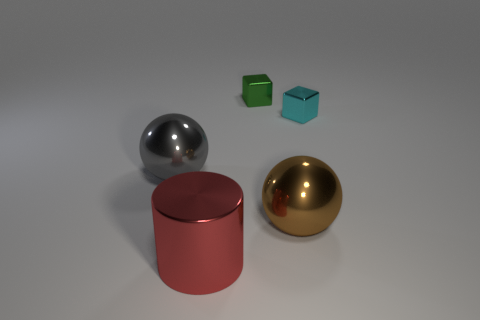Is the size of the shiny cylinder the same as the green metal cube?
Keep it short and to the point. No. Is the material of the large ball right of the large gray shiny ball the same as the tiny object that is behind the small cyan metal object?
Offer a very short reply. Yes. The object behind the small cube that is on the right side of the metal sphere on the right side of the gray shiny sphere is what shape?
Ensure brevity in your answer.  Cube. Is the number of large green objects greater than the number of gray spheres?
Your answer should be very brief. No. Are any green metallic blocks visible?
Provide a succinct answer. Yes. How many objects are tiny things that are left of the cyan object or metal objects to the left of the cylinder?
Make the answer very short. 2. Are there fewer tiny blue matte blocks than gray shiny things?
Ensure brevity in your answer.  Yes. There is a large gray shiny ball; are there any red cylinders left of it?
Your answer should be compact. No. Do the red thing and the cyan object have the same material?
Ensure brevity in your answer.  Yes. There is another big thing that is the same shape as the big gray thing; what color is it?
Your answer should be very brief. Brown. 